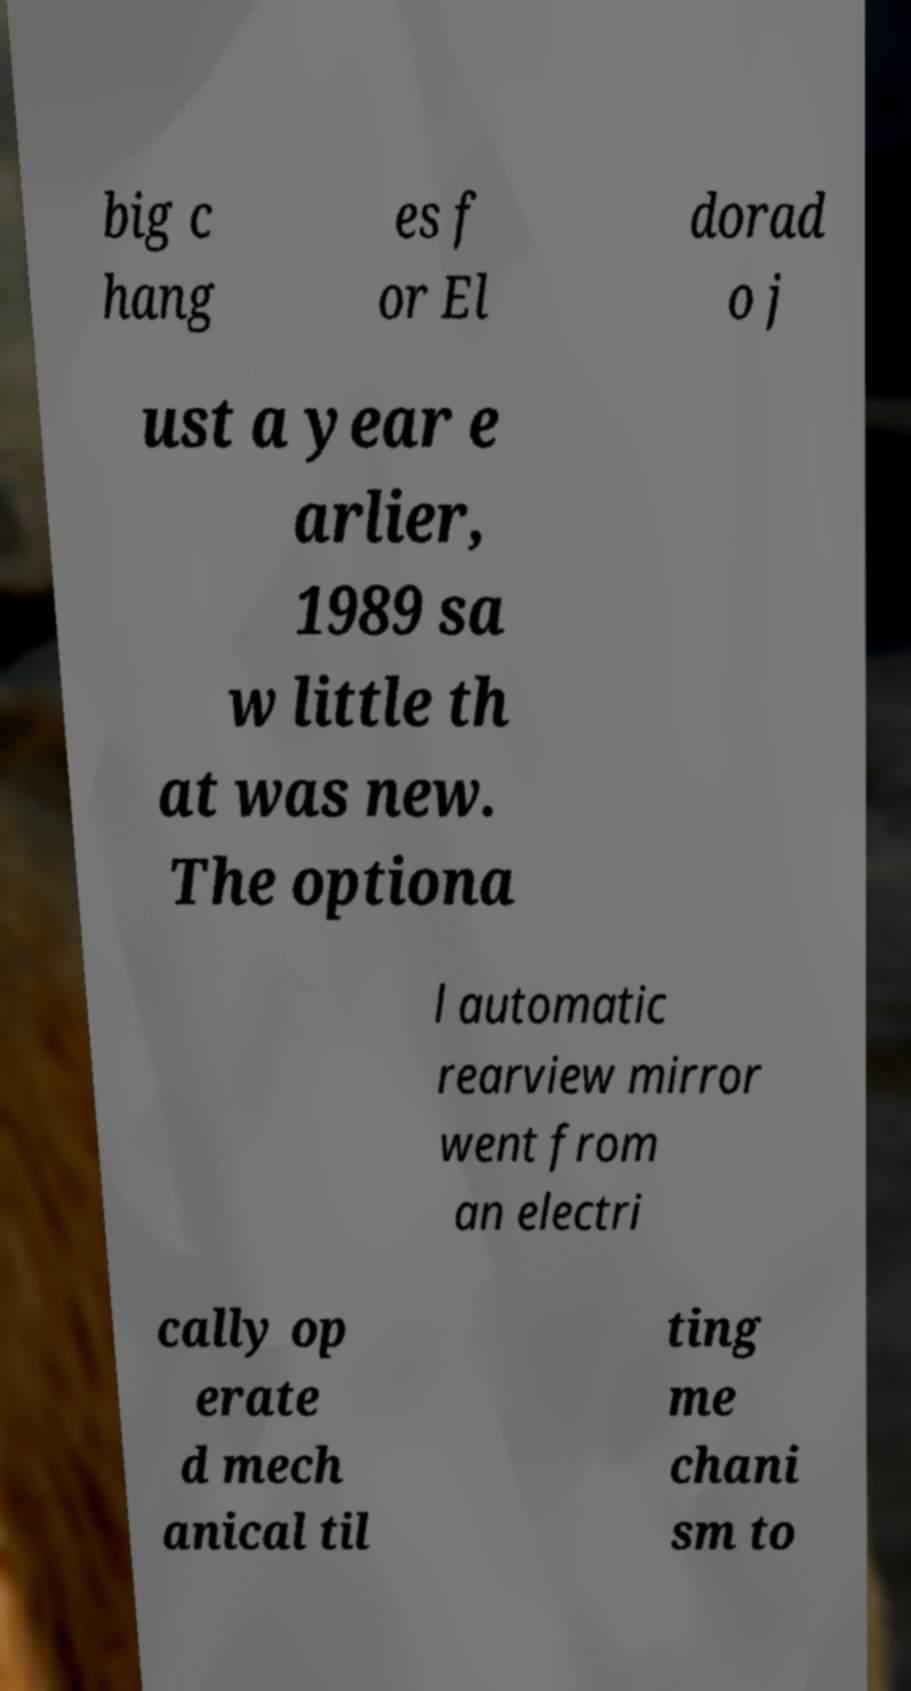I need the written content from this picture converted into text. Can you do that? big c hang es f or El dorad o j ust a year e arlier, 1989 sa w little th at was new. The optiona l automatic rearview mirror went from an electri cally op erate d mech anical til ting me chani sm to 